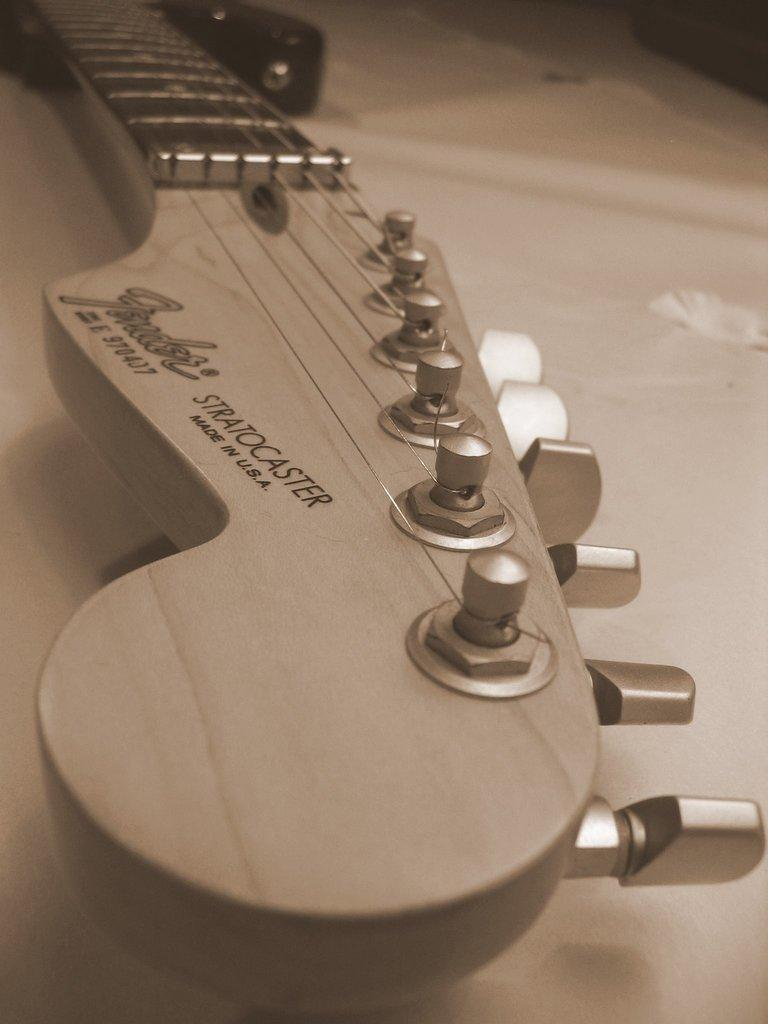What musical instrument is present in the image? There is a guitar in the image. Where is the guitar located? The guitar is placed on a table. What type of meal is being prepared on the guitar in the image? There is no meal being prepared on the guitar in the image, as it is a musical instrument and not a cooking surface. 